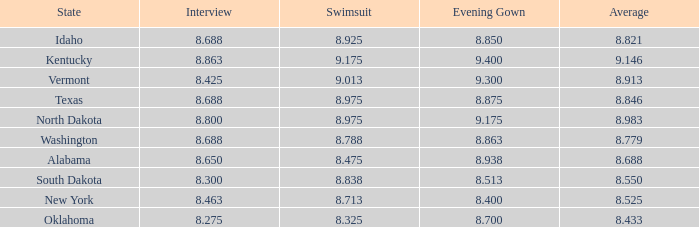What is the minimum average for a contestant who has an 8.275 interview score and an evening gown score higher than 8.7? None. 